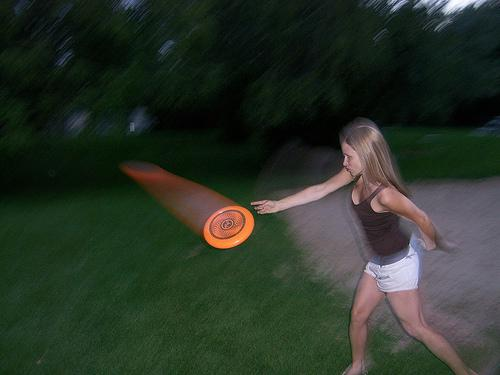Question: what color is the frisbee?
Choices:
A. Orange.
B. Pink.
C. Blue.
D. Red.
Answer with the letter. Answer: A Question: what color is the woman's hair?
Choices:
A. Red.
B. Brown.
C. Black.
D. Blonde.
Answer with the letter. Answer: D Question: what is the woman standing on?
Choices:
A. The grass.
B. A table.
C. The floor.
D. The roof.
Answer with the letter. Answer: A Question: what color are the designs on the frisbee?
Choices:
A. Pink.
B. Blue.
C. Black.
D. Red.
Answer with the letter. Answer: C 